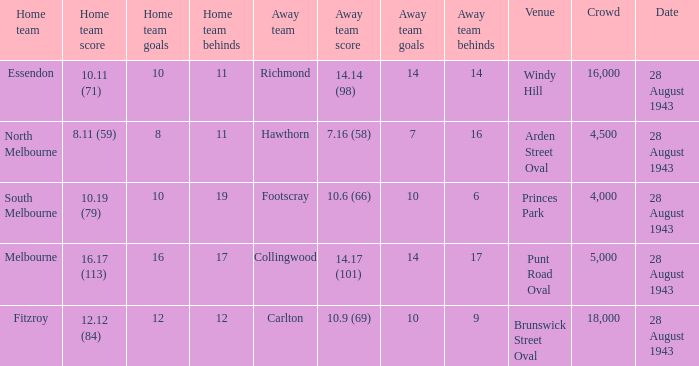Where was the game played with an away team score of 14.17 (101)? Punt Road Oval. 